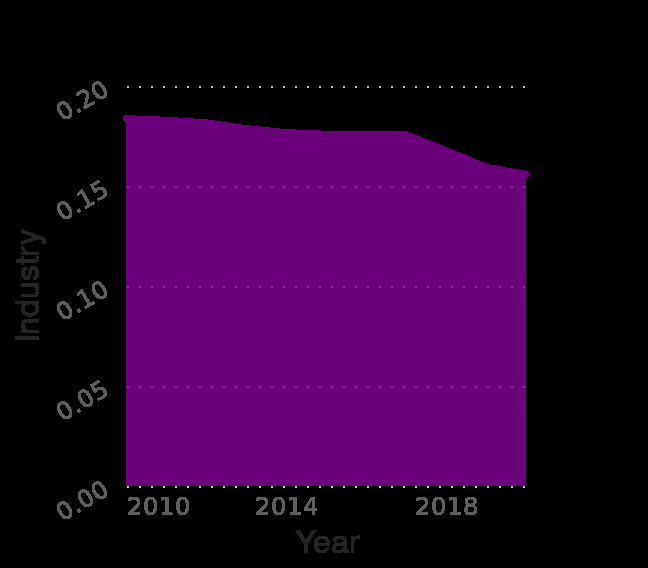<image>
How much did the industry value number decrease from 2010 to 2018?  The industry value number decreased by 0.03 from 2010 to 2018. What was the average annual rate of decrease in the industry value number from 2010 to 2018? The average annual rate of decrease in the industry value number from 2010 to 2018 was 0.004 per year. What does the x-axis measure in the Nicaragua employment diagram? The x-axis in the Nicaragua employment diagram measures the year from 2010 to 2018. 